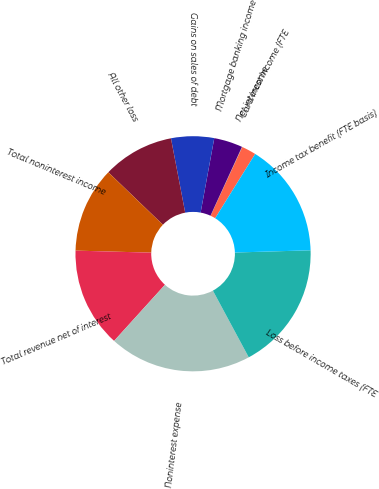Convert chart. <chart><loc_0><loc_0><loc_500><loc_500><pie_chart><fcel>Net interest income (FTE<fcel>Card income<fcel>Mortgage banking income<fcel>Gains on sales of debt<fcel>All other loss<fcel>Total noninterest income<fcel>Total revenue net of interest<fcel>Noninterest expense<fcel>Loss before income taxes (FTE<fcel>Income tax benefit (FTE basis)<nl><fcel>1.99%<fcel>0.04%<fcel>3.94%<fcel>5.9%<fcel>9.8%<fcel>11.76%<fcel>13.71%<fcel>19.57%<fcel>17.62%<fcel>15.67%<nl></chart> 